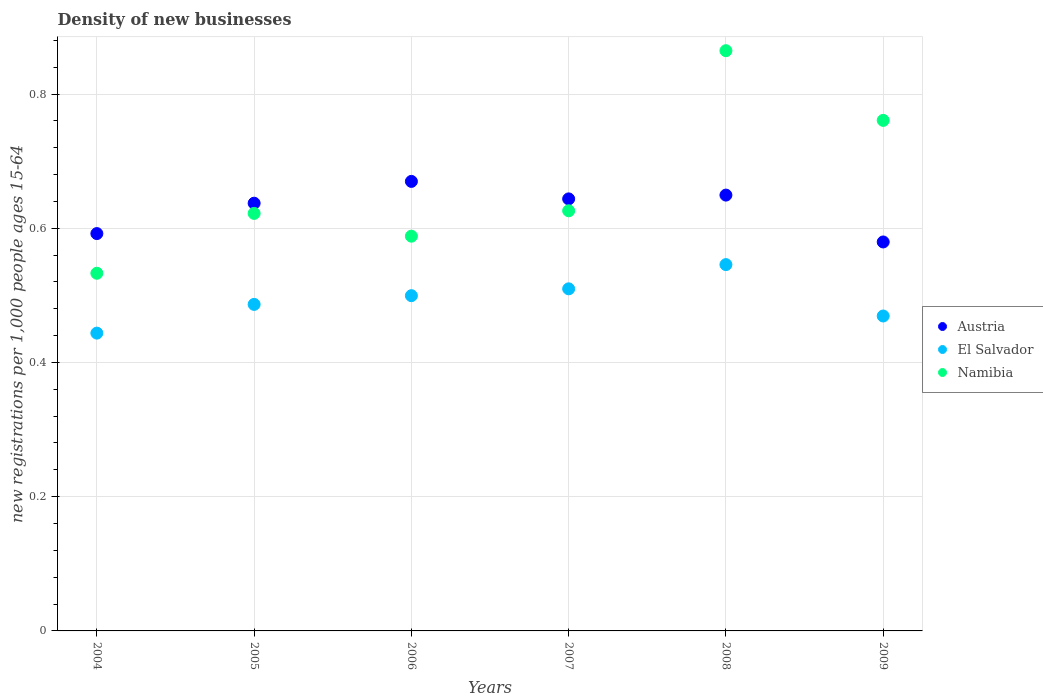Is the number of dotlines equal to the number of legend labels?
Ensure brevity in your answer.  Yes. What is the number of new registrations in Namibia in 2007?
Provide a short and direct response. 0.63. Across all years, what is the maximum number of new registrations in Namibia?
Provide a succinct answer. 0.86. Across all years, what is the minimum number of new registrations in El Salvador?
Offer a very short reply. 0.44. In which year was the number of new registrations in Austria maximum?
Offer a terse response. 2006. In which year was the number of new registrations in Namibia minimum?
Provide a succinct answer. 2004. What is the total number of new registrations in El Salvador in the graph?
Your answer should be compact. 2.95. What is the difference between the number of new registrations in Namibia in 2004 and that in 2006?
Your answer should be very brief. -0.06. What is the difference between the number of new registrations in Austria in 2004 and the number of new registrations in Namibia in 2007?
Your response must be concise. -0.03. What is the average number of new registrations in Austria per year?
Offer a terse response. 0.63. In the year 2005, what is the difference between the number of new registrations in Namibia and number of new registrations in El Salvador?
Make the answer very short. 0.14. In how many years, is the number of new registrations in Austria greater than 0.28?
Provide a short and direct response. 6. What is the ratio of the number of new registrations in El Salvador in 2004 to that in 2009?
Offer a very short reply. 0.95. What is the difference between the highest and the second highest number of new registrations in Namibia?
Your response must be concise. 0.1. What is the difference between the highest and the lowest number of new registrations in Austria?
Ensure brevity in your answer.  0.09. Is the sum of the number of new registrations in Austria in 2004 and 2008 greater than the maximum number of new registrations in Namibia across all years?
Offer a terse response. Yes. Is the number of new registrations in Namibia strictly greater than the number of new registrations in El Salvador over the years?
Your response must be concise. Yes. Is the number of new registrations in Namibia strictly less than the number of new registrations in Austria over the years?
Offer a very short reply. No. What is the difference between two consecutive major ticks on the Y-axis?
Your response must be concise. 0.2. Does the graph contain any zero values?
Offer a very short reply. No. Does the graph contain grids?
Make the answer very short. Yes. Where does the legend appear in the graph?
Provide a short and direct response. Center right. What is the title of the graph?
Make the answer very short. Density of new businesses. Does "Cayman Islands" appear as one of the legend labels in the graph?
Your response must be concise. No. What is the label or title of the X-axis?
Your response must be concise. Years. What is the label or title of the Y-axis?
Provide a succinct answer. New registrations per 1,0 people ages 15-64. What is the new registrations per 1,000 people ages 15-64 in Austria in 2004?
Keep it short and to the point. 0.59. What is the new registrations per 1,000 people ages 15-64 in El Salvador in 2004?
Offer a very short reply. 0.44. What is the new registrations per 1,000 people ages 15-64 in Namibia in 2004?
Give a very brief answer. 0.53. What is the new registrations per 1,000 people ages 15-64 of Austria in 2005?
Provide a short and direct response. 0.64. What is the new registrations per 1,000 people ages 15-64 in El Salvador in 2005?
Offer a terse response. 0.49. What is the new registrations per 1,000 people ages 15-64 of Namibia in 2005?
Your response must be concise. 0.62. What is the new registrations per 1,000 people ages 15-64 in Austria in 2006?
Your answer should be compact. 0.67. What is the new registrations per 1,000 people ages 15-64 of El Salvador in 2006?
Offer a very short reply. 0.5. What is the new registrations per 1,000 people ages 15-64 in Namibia in 2006?
Offer a terse response. 0.59. What is the new registrations per 1,000 people ages 15-64 in Austria in 2007?
Your answer should be compact. 0.64. What is the new registrations per 1,000 people ages 15-64 of El Salvador in 2007?
Your response must be concise. 0.51. What is the new registrations per 1,000 people ages 15-64 in Namibia in 2007?
Ensure brevity in your answer.  0.63. What is the new registrations per 1,000 people ages 15-64 in Austria in 2008?
Keep it short and to the point. 0.65. What is the new registrations per 1,000 people ages 15-64 of El Salvador in 2008?
Give a very brief answer. 0.55. What is the new registrations per 1,000 people ages 15-64 of Namibia in 2008?
Provide a succinct answer. 0.86. What is the new registrations per 1,000 people ages 15-64 in Austria in 2009?
Ensure brevity in your answer.  0.58. What is the new registrations per 1,000 people ages 15-64 of El Salvador in 2009?
Give a very brief answer. 0.47. What is the new registrations per 1,000 people ages 15-64 of Namibia in 2009?
Your answer should be compact. 0.76. Across all years, what is the maximum new registrations per 1,000 people ages 15-64 in Austria?
Offer a terse response. 0.67. Across all years, what is the maximum new registrations per 1,000 people ages 15-64 in El Salvador?
Your answer should be compact. 0.55. Across all years, what is the maximum new registrations per 1,000 people ages 15-64 in Namibia?
Your answer should be very brief. 0.86. Across all years, what is the minimum new registrations per 1,000 people ages 15-64 in Austria?
Offer a terse response. 0.58. Across all years, what is the minimum new registrations per 1,000 people ages 15-64 in El Salvador?
Make the answer very short. 0.44. Across all years, what is the minimum new registrations per 1,000 people ages 15-64 of Namibia?
Offer a terse response. 0.53. What is the total new registrations per 1,000 people ages 15-64 in Austria in the graph?
Your answer should be very brief. 3.77. What is the total new registrations per 1,000 people ages 15-64 in El Salvador in the graph?
Provide a succinct answer. 2.95. What is the total new registrations per 1,000 people ages 15-64 in Namibia in the graph?
Offer a terse response. 3.99. What is the difference between the new registrations per 1,000 people ages 15-64 in Austria in 2004 and that in 2005?
Your answer should be very brief. -0.05. What is the difference between the new registrations per 1,000 people ages 15-64 of El Salvador in 2004 and that in 2005?
Keep it short and to the point. -0.04. What is the difference between the new registrations per 1,000 people ages 15-64 in Namibia in 2004 and that in 2005?
Your answer should be very brief. -0.09. What is the difference between the new registrations per 1,000 people ages 15-64 in Austria in 2004 and that in 2006?
Offer a terse response. -0.08. What is the difference between the new registrations per 1,000 people ages 15-64 in El Salvador in 2004 and that in 2006?
Keep it short and to the point. -0.06. What is the difference between the new registrations per 1,000 people ages 15-64 of Namibia in 2004 and that in 2006?
Ensure brevity in your answer.  -0.06. What is the difference between the new registrations per 1,000 people ages 15-64 in Austria in 2004 and that in 2007?
Make the answer very short. -0.05. What is the difference between the new registrations per 1,000 people ages 15-64 of El Salvador in 2004 and that in 2007?
Offer a terse response. -0.07. What is the difference between the new registrations per 1,000 people ages 15-64 of Namibia in 2004 and that in 2007?
Make the answer very short. -0.09. What is the difference between the new registrations per 1,000 people ages 15-64 of Austria in 2004 and that in 2008?
Make the answer very short. -0.06. What is the difference between the new registrations per 1,000 people ages 15-64 in El Salvador in 2004 and that in 2008?
Provide a succinct answer. -0.1. What is the difference between the new registrations per 1,000 people ages 15-64 in Namibia in 2004 and that in 2008?
Make the answer very short. -0.33. What is the difference between the new registrations per 1,000 people ages 15-64 in Austria in 2004 and that in 2009?
Provide a short and direct response. 0.01. What is the difference between the new registrations per 1,000 people ages 15-64 in El Salvador in 2004 and that in 2009?
Keep it short and to the point. -0.03. What is the difference between the new registrations per 1,000 people ages 15-64 in Namibia in 2004 and that in 2009?
Offer a terse response. -0.23. What is the difference between the new registrations per 1,000 people ages 15-64 of Austria in 2005 and that in 2006?
Keep it short and to the point. -0.03. What is the difference between the new registrations per 1,000 people ages 15-64 in El Salvador in 2005 and that in 2006?
Make the answer very short. -0.01. What is the difference between the new registrations per 1,000 people ages 15-64 in Namibia in 2005 and that in 2006?
Make the answer very short. 0.03. What is the difference between the new registrations per 1,000 people ages 15-64 in Austria in 2005 and that in 2007?
Your answer should be very brief. -0.01. What is the difference between the new registrations per 1,000 people ages 15-64 in El Salvador in 2005 and that in 2007?
Keep it short and to the point. -0.02. What is the difference between the new registrations per 1,000 people ages 15-64 in Namibia in 2005 and that in 2007?
Keep it short and to the point. -0. What is the difference between the new registrations per 1,000 people ages 15-64 of Austria in 2005 and that in 2008?
Offer a terse response. -0.01. What is the difference between the new registrations per 1,000 people ages 15-64 of El Salvador in 2005 and that in 2008?
Offer a terse response. -0.06. What is the difference between the new registrations per 1,000 people ages 15-64 of Namibia in 2005 and that in 2008?
Provide a short and direct response. -0.24. What is the difference between the new registrations per 1,000 people ages 15-64 of Austria in 2005 and that in 2009?
Ensure brevity in your answer.  0.06. What is the difference between the new registrations per 1,000 people ages 15-64 of El Salvador in 2005 and that in 2009?
Your answer should be very brief. 0.02. What is the difference between the new registrations per 1,000 people ages 15-64 in Namibia in 2005 and that in 2009?
Offer a terse response. -0.14. What is the difference between the new registrations per 1,000 people ages 15-64 of Austria in 2006 and that in 2007?
Ensure brevity in your answer.  0.03. What is the difference between the new registrations per 1,000 people ages 15-64 in El Salvador in 2006 and that in 2007?
Offer a very short reply. -0.01. What is the difference between the new registrations per 1,000 people ages 15-64 in Namibia in 2006 and that in 2007?
Give a very brief answer. -0.04. What is the difference between the new registrations per 1,000 people ages 15-64 in Austria in 2006 and that in 2008?
Your response must be concise. 0.02. What is the difference between the new registrations per 1,000 people ages 15-64 of El Salvador in 2006 and that in 2008?
Give a very brief answer. -0.05. What is the difference between the new registrations per 1,000 people ages 15-64 in Namibia in 2006 and that in 2008?
Make the answer very short. -0.28. What is the difference between the new registrations per 1,000 people ages 15-64 of Austria in 2006 and that in 2009?
Offer a very short reply. 0.09. What is the difference between the new registrations per 1,000 people ages 15-64 in El Salvador in 2006 and that in 2009?
Give a very brief answer. 0.03. What is the difference between the new registrations per 1,000 people ages 15-64 of Namibia in 2006 and that in 2009?
Offer a terse response. -0.17. What is the difference between the new registrations per 1,000 people ages 15-64 of Austria in 2007 and that in 2008?
Keep it short and to the point. -0.01. What is the difference between the new registrations per 1,000 people ages 15-64 of El Salvador in 2007 and that in 2008?
Provide a succinct answer. -0.04. What is the difference between the new registrations per 1,000 people ages 15-64 of Namibia in 2007 and that in 2008?
Give a very brief answer. -0.24. What is the difference between the new registrations per 1,000 people ages 15-64 in Austria in 2007 and that in 2009?
Make the answer very short. 0.06. What is the difference between the new registrations per 1,000 people ages 15-64 in El Salvador in 2007 and that in 2009?
Your answer should be very brief. 0.04. What is the difference between the new registrations per 1,000 people ages 15-64 of Namibia in 2007 and that in 2009?
Your answer should be very brief. -0.13. What is the difference between the new registrations per 1,000 people ages 15-64 of Austria in 2008 and that in 2009?
Make the answer very short. 0.07. What is the difference between the new registrations per 1,000 people ages 15-64 of El Salvador in 2008 and that in 2009?
Give a very brief answer. 0.08. What is the difference between the new registrations per 1,000 people ages 15-64 in Namibia in 2008 and that in 2009?
Offer a very short reply. 0.1. What is the difference between the new registrations per 1,000 people ages 15-64 of Austria in 2004 and the new registrations per 1,000 people ages 15-64 of El Salvador in 2005?
Offer a very short reply. 0.11. What is the difference between the new registrations per 1,000 people ages 15-64 in Austria in 2004 and the new registrations per 1,000 people ages 15-64 in Namibia in 2005?
Your answer should be compact. -0.03. What is the difference between the new registrations per 1,000 people ages 15-64 in El Salvador in 2004 and the new registrations per 1,000 people ages 15-64 in Namibia in 2005?
Ensure brevity in your answer.  -0.18. What is the difference between the new registrations per 1,000 people ages 15-64 in Austria in 2004 and the new registrations per 1,000 people ages 15-64 in El Salvador in 2006?
Your answer should be very brief. 0.09. What is the difference between the new registrations per 1,000 people ages 15-64 in Austria in 2004 and the new registrations per 1,000 people ages 15-64 in Namibia in 2006?
Your answer should be very brief. 0. What is the difference between the new registrations per 1,000 people ages 15-64 in El Salvador in 2004 and the new registrations per 1,000 people ages 15-64 in Namibia in 2006?
Provide a succinct answer. -0.14. What is the difference between the new registrations per 1,000 people ages 15-64 in Austria in 2004 and the new registrations per 1,000 people ages 15-64 in El Salvador in 2007?
Your response must be concise. 0.08. What is the difference between the new registrations per 1,000 people ages 15-64 of Austria in 2004 and the new registrations per 1,000 people ages 15-64 of Namibia in 2007?
Give a very brief answer. -0.03. What is the difference between the new registrations per 1,000 people ages 15-64 of El Salvador in 2004 and the new registrations per 1,000 people ages 15-64 of Namibia in 2007?
Provide a succinct answer. -0.18. What is the difference between the new registrations per 1,000 people ages 15-64 of Austria in 2004 and the new registrations per 1,000 people ages 15-64 of El Salvador in 2008?
Give a very brief answer. 0.05. What is the difference between the new registrations per 1,000 people ages 15-64 in Austria in 2004 and the new registrations per 1,000 people ages 15-64 in Namibia in 2008?
Your answer should be compact. -0.27. What is the difference between the new registrations per 1,000 people ages 15-64 of El Salvador in 2004 and the new registrations per 1,000 people ages 15-64 of Namibia in 2008?
Your response must be concise. -0.42. What is the difference between the new registrations per 1,000 people ages 15-64 of Austria in 2004 and the new registrations per 1,000 people ages 15-64 of El Salvador in 2009?
Your answer should be compact. 0.12. What is the difference between the new registrations per 1,000 people ages 15-64 of Austria in 2004 and the new registrations per 1,000 people ages 15-64 of Namibia in 2009?
Make the answer very short. -0.17. What is the difference between the new registrations per 1,000 people ages 15-64 in El Salvador in 2004 and the new registrations per 1,000 people ages 15-64 in Namibia in 2009?
Offer a very short reply. -0.32. What is the difference between the new registrations per 1,000 people ages 15-64 in Austria in 2005 and the new registrations per 1,000 people ages 15-64 in El Salvador in 2006?
Make the answer very short. 0.14. What is the difference between the new registrations per 1,000 people ages 15-64 in Austria in 2005 and the new registrations per 1,000 people ages 15-64 in Namibia in 2006?
Your answer should be compact. 0.05. What is the difference between the new registrations per 1,000 people ages 15-64 of El Salvador in 2005 and the new registrations per 1,000 people ages 15-64 of Namibia in 2006?
Your answer should be compact. -0.1. What is the difference between the new registrations per 1,000 people ages 15-64 in Austria in 2005 and the new registrations per 1,000 people ages 15-64 in El Salvador in 2007?
Your response must be concise. 0.13. What is the difference between the new registrations per 1,000 people ages 15-64 of Austria in 2005 and the new registrations per 1,000 people ages 15-64 of Namibia in 2007?
Make the answer very short. 0.01. What is the difference between the new registrations per 1,000 people ages 15-64 in El Salvador in 2005 and the new registrations per 1,000 people ages 15-64 in Namibia in 2007?
Your answer should be very brief. -0.14. What is the difference between the new registrations per 1,000 people ages 15-64 of Austria in 2005 and the new registrations per 1,000 people ages 15-64 of El Salvador in 2008?
Provide a short and direct response. 0.09. What is the difference between the new registrations per 1,000 people ages 15-64 of Austria in 2005 and the new registrations per 1,000 people ages 15-64 of Namibia in 2008?
Offer a very short reply. -0.23. What is the difference between the new registrations per 1,000 people ages 15-64 in El Salvador in 2005 and the new registrations per 1,000 people ages 15-64 in Namibia in 2008?
Give a very brief answer. -0.38. What is the difference between the new registrations per 1,000 people ages 15-64 of Austria in 2005 and the new registrations per 1,000 people ages 15-64 of El Salvador in 2009?
Your response must be concise. 0.17. What is the difference between the new registrations per 1,000 people ages 15-64 of Austria in 2005 and the new registrations per 1,000 people ages 15-64 of Namibia in 2009?
Your answer should be very brief. -0.12. What is the difference between the new registrations per 1,000 people ages 15-64 in El Salvador in 2005 and the new registrations per 1,000 people ages 15-64 in Namibia in 2009?
Offer a terse response. -0.27. What is the difference between the new registrations per 1,000 people ages 15-64 of Austria in 2006 and the new registrations per 1,000 people ages 15-64 of El Salvador in 2007?
Give a very brief answer. 0.16. What is the difference between the new registrations per 1,000 people ages 15-64 of Austria in 2006 and the new registrations per 1,000 people ages 15-64 of Namibia in 2007?
Offer a very short reply. 0.04. What is the difference between the new registrations per 1,000 people ages 15-64 of El Salvador in 2006 and the new registrations per 1,000 people ages 15-64 of Namibia in 2007?
Offer a terse response. -0.13. What is the difference between the new registrations per 1,000 people ages 15-64 in Austria in 2006 and the new registrations per 1,000 people ages 15-64 in El Salvador in 2008?
Provide a succinct answer. 0.12. What is the difference between the new registrations per 1,000 people ages 15-64 of Austria in 2006 and the new registrations per 1,000 people ages 15-64 of Namibia in 2008?
Give a very brief answer. -0.19. What is the difference between the new registrations per 1,000 people ages 15-64 in El Salvador in 2006 and the new registrations per 1,000 people ages 15-64 in Namibia in 2008?
Offer a very short reply. -0.36. What is the difference between the new registrations per 1,000 people ages 15-64 in Austria in 2006 and the new registrations per 1,000 people ages 15-64 in El Salvador in 2009?
Your answer should be very brief. 0.2. What is the difference between the new registrations per 1,000 people ages 15-64 of Austria in 2006 and the new registrations per 1,000 people ages 15-64 of Namibia in 2009?
Offer a terse response. -0.09. What is the difference between the new registrations per 1,000 people ages 15-64 in El Salvador in 2006 and the new registrations per 1,000 people ages 15-64 in Namibia in 2009?
Ensure brevity in your answer.  -0.26. What is the difference between the new registrations per 1,000 people ages 15-64 of Austria in 2007 and the new registrations per 1,000 people ages 15-64 of El Salvador in 2008?
Provide a short and direct response. 0.1. What is the difference between the new registrations per 1,000 people ages 15-64 in Austria in 2007 and the new registrations per 1,000 people ages 15-64 in Namibia in 2008?
Your response must be concise. -0.22. What is the difference between the new registrations per 1,000 people ages 15-64 of El Salvador in 2007 and the new registrations per 1,000 people ages 15-64 of Namibia in 2008?
Your answer should be very brief. -0.35. What is the difference between the new registrations per 1,000 people ages 15-64 in Austria in 2007 and the new registrations per 1,000 people ages 15-64 in El Salvador in 2009?
Your response must be concise. 0.17. What is the difference between the new registrations per 1,000 people ages 15-64 of Austria in 2007 and the new registrations per 1,000 people ages 15-64 of Namibia in 2009?
Provide a short and direct response. -0.12. What is the difference between the new registrations per 1,000 people ages 15-64 of El Salvador in 2007 and the new registrations per 1,000 people ages 15-64 of Namibia in 2009?
Provide a short and direct response. -0.25. What is the difference between the new registrations per 1,000 people ages 15-64 of Austria in 2008 and the new registrations per 1,000 people ages 15-64 of El Salvador in 2009?
Your response must be concise. 0.18. What is the difference between the new registrations per 1,000 people ages 15-64 in Austria in 2008 and the new registrations per 1,000 people ages 15-64 in Namibia in 2009?
Provide a succinct answer. -0.11. What is the difference between the new registrations per 1,000 people ages 15-64 in El Salvador in 2008 and the new registrations per 1,000 people ages 15-64 in Namibia in 2009?
Your answer should be very brief. -0.21. What is the average new registrations per 1,000 people ages 15-64 in Austria per year?
Your response must be concise. 0.63. What is the average new registrations per 1,000 people ages 15-64 of El Salvador per year?
Give a very brief answer. 0.49. What is the average new registrations per 1,000 people ages 15-64 in Namibia per year?
Ensure brevity in your answer.  0.67. In the year 2004, what is the difference between the new registrations per 1,000 people ages 15-64 of Austria and new registrations per 1,000 people ages 15-64 of El Salvador?
Make the answer very short. 0.15. In the year 2004, what is the difference between the new registrations per 1,000 people ages 15-64 of Austria and new registrations per 1,000 people ages 15-64 of Namibia?
Provide a short and direct response. 0.06. In the year 2004, what is the difference between the new registrations per 1,000 people ages 15-64 in El Salvador and new registrations per 1,000 people ages 15-64 in Namibia?
Make the answer very short. -0.09. In the year 2005, what is the difference between the new registrations per 1,000 people ages 15-64 in Austria and new registrations per 1,000 people ages 15-64 in El Salvador?
Your response must be concise. 0.15. In the year 2005, what is the difference between the new registrations per 1,000 people ages 15-64 of Austria and new registrations per 1,000 people ages 15-64 of Namibia?
Provide a succinct answer. 0.02. In the year 2005, what is the difference between the new registrations per 1,000 people ages 15-64 in El Salvador and new registrations per 1,000 people ages 15-64 in Namibia?
Offer a very short reply. -0.14. In the year 2006, what is the difference between the new registrations per 1,000 people ages 15-64 of Austria and new registrations per 1,000 people ages 15-64 of El Salvador?
Provide a succinct answer. 0.17. In the year 2006, what is the difference between the new registrations per 1,000 people ages 15-64 in Austria and new registrations per 1,000 people ages 15-64 in Namibia?
Offer a terse response. 0.08. In the year 2006, what is the difference between the new registrations per 1,000 people ages 15-64 of El Salvador and new registrations per 1,000 people ages 15-64 of Namibia?
Make the answer very short. -0.09. In the year 2007, what is the difference between the new registrations per 1,000 people ages 15-64 in Austria and new registrations per 1,000 people ages 15-64 in El Salvador?
Provide a short and direct response. 0.13. In the year 2007, what is the difference between the new registrations per 1,000 people ages 15-64 in Austria and new registrations per 1,000 people ages 15-64 in Namibia?
Give a very brief answer. 0.02. In the year 2007, what is the difference between the new registrations per 1,000 people ages 15-64 of El Salvador and new registrations per 1,000 people ages 15-64 of Namibia?
Give a very brief answer. -0.12. In the year 2008, what is the difference between the new registrations per 1,000 people ages 15-64 in Austria and new registrations per 1,000 people ages 15-64 in El Salvador?
Offer a very short reply. 0.1. In the year 2008, what is the difference between the new registrations per 1,000 people ages 15-64 of Austria and new registrations per 1,000 people ages 15-64 of Namibia?
Your response must be concise. -0.22. In the year 2008, what is the difference between the new registrations per 1,000 people ages 15-64 in El Salvador and new registrations per 1,000 people ages 15-64 in Namibia?
Make the answer very short. -0.32. In the year 2009, what is the difference between the new registrations per 1,000 people ages 15-64 of Austria and new registrations per 1,000 people ages 15-64 of El Salvador?
Provide a short and direct response. 0.11. In the year 2009, what is the difference between the new registrations per 1,000 people ages 15-64 in Austria and new registrations per 1,000 people ages 15-64 in Namibia?
Give a very brief answer. -0.18. In the year 2009, what is the difference between the new registrations per 1,000 people ages 15-64 of El Salvador and new registrations per 1,000 people ages 15-64 of Namibia?
Keep it short and to the point. -0.29. What is the ratio of the new registrations per 1,000 people ages 15-64 in Austria in 2004 to that in 2005?
Your response must be concise. 0.93. What is the ratio of the new registrations per 1,000 people ages 15-64 in El Salvador in 2004 to that in 2005?
Provide a short and direct response. 0.91. What is the ratio of the new registrations per 1,000 people ages 15-64 of Namibia in 2004 to that in 2005?
Offer a terse response. 0.86. What is the ratio of the new registrations per 1,000 people ages 15-64 in Austria in 2004 to that in 2006?
Ensure brevity in your answer.  0.88. What is the ratio of the new registrations per 1,000 people ages 15-64 in El Salvador in 2004 to that in 2006?
Give a very brief answer. 0.89. What is the ratio of the new registrations per 1,000 people ages 15-64 of Namibia in 2004 to that in 2006?
Make the answer very short. 0.91. What is the ratio of the new registrations per 1,000 people ages 15-64 in Austria in 2004 to that in 2007?
Offer a terse response. 0.92. What is the ratio of the new registrations per 1,000 people ages 15-64 of El Salvador in 2004 to that in 2007?
Make the answer very short. 0.87. What is the ratio of the new registrations per 1,000 people ages 15-64 of Namibia in 2004 to that in 2007?
Your answer should be compact. 0.85. What is the ratio of the new registrations per 1,000 people ages 15-64 of Austria in 2004 to that in 2008?
Offer a very short reply. 0.91. What is the ratio of the new registrations per 1,000 people ages 15-64 of El Salvador in 2004 to that in 2008?
Your answer should be very brief. 0.81. What is the ratio of the new registrations per 1,000 people ages 15-64 in Namibia in 2004 to that in 2008?
Give a very brief answer. 0.62. What is the ratio of the new registrations per 1,000 people ages 15-64 in Austria in 2004 to that in 2009?
Make the answer very short. 1.02. What is the ratio of the new registrations per 1,000 people ages 15-64 of El Salvador in 2004 to that in 2009?
Provide a short and direct response. 0.95. What is the ratio of the new registrations per 1,000 people ages 15-64 of Namibia in 2004 to that in 2009?
Make the answer very short. 0.7. What is the ratio of the new registrations per 1,000 people ages 15-64 of Austria in 2005 to that in 2006?
Your answer should be very brief. 0.95. What is the ratio of the new registrations per 1,000 people ages 15-64 of El Salvador in 2005 to that in 2006?
Make the answer very short. 0.97. What is the ratio of the new registrations per 1,000 people ages 15-64 of Namibia in 2005 to that in 2006?
Your answer should be compact. 1.06. What is the ratio of the new registrations per 1,000 people ages 15-64 in El Salvador in 2005 to that in 2007?
Keep it short and to the point. 0.95. What is the ratio of the new registrations per 1,000 people ages 15-64 of Austria in 2005 to that in 2008?
Provide a succinct answer. 0.98. What is the ratio of the new registrations per 1,000 people ages 15-64 in El Salvador in 2005 to that in 2008?
Ensure brevity in your answer.  0.89. What is the ratio of the new registrations per 1,000 people ages 15-64 in Namibia in 2005 to that in 2008?
Provide a short and direct response. 0.72. What is the ratio of the new registrations per 1,000 people ages 15-64 in Austria in 2005 to that in 2009?
Make the answer very short. 1.1. What is the ratio of the new registrations per 1,000 people ages 15-64 of El Salvador in 2005 to that in 2009?
Give a very brief answer. 1.04. What is the ratio of the new registrations per 1,000 people ages 15-64 in Namibia in 2005 to that in 2009?
Make the answer very short. 0.82. What is the ratio of the new registrations per 1,000 people ages 15-64 in Austria in 2006 to that in 2007?
Give a very brief answer. 1.04. What is the ratio of the new registrations per 1,000 people ages 15-64 in Namibia in 2006 to that in 2007?
Provide a short and direct response. 0.94. What is the ratio of the new registrations per 1,000 people ages 15-64 in Austria in 2006 to that in 2008?
Make the answer very short. 1.03. What is the ratio of the new registrations per 1,000 people ages 15-64 in El Salvador in 2006 to that in 2008?
Provide a short and direct response. 0.92. What is the ratio of the new registrations per 1,000 people ages 15-64 of Namibia in 2006 to that in 2008?
Offer a very short reply. 0.68. What is the ratio of the new registrations per 1,000 people ages 15-64 of Austria in 2006 to that in 2009?
Provide a short and direct response. 1.16. What is the ratio of the new registrations per 1,000 people ages 15-64 of El Salvador in 2006 to that in 2009?
Your answer should be compact. 1.06. What is the ratio of the new registrations per 1,000 people ages 15-64 in Namibia in 2006 to that in 2009?
Offer a very short reply. 0.77. What is the ratio of the new registrations per 1,000 people ages 15-64 of El Salvador in 2007 to that in 2008?
Your response must be concise. 0.93. What is the ratio of the new registrations per 1,000 people ages 15-64 of Namibia in 2007 to that in 2008?
Ensure brevity in your answer.  0.72. What is the ratio of the new registrations per 1,000 people ages 15-64 in Austria in 2007 to that in 2009?
Your response must be concise. 1.11. What is the ratio of the new registrations per 1,000 people ages 15-64 in El Salvador in 2007 to that in 2009?
Offer a terse response. 1.09. What is the ratio of the new registrations per 1,000 people ages 15-64 in Namibia in 2007 to that in 2009?
Offer a terse response. 0.82. What is the ratio of the new registrations per 1,000 people ages 15-64 of Austria in 2008 to that in 2009?
Provide a short and direct response. 1.12. What is the ratio of the new registrations per 1,000 people ages 15-64 of El Salvador in 2008 to that in 2009?
Provide a succinct answer. 1.16. What is the ratio of the new registrations per 1,000 people ages 15-64 of Namibia in 2008 to that in 2009?
Offer a terse response. 1.14. What is the difference between the highest and the second highest new registrations per 1,000 people ages 15-64 in Austria?
Your response must be concise. 0.02. What is the difference between the highest and the second highest new registrations per 1,000 people ages 15-64 of El Salvador?
Your response must be concise. 0.04. What is the difference between the highest and the second highest new registrations per 1,000 people ages 15-64 of Namibia?
Offer a very short reply. 0.1. What is the difference between the highest and the lowest new registrations per 1,000 people ages 15-64 of Austria?
Your answer should be compact. 0.09. What is the difference between the highest and the lowest new registrations per 1,000 people ages 15-64 of El Salvador?
Give a very brief answer. 0.1. What is the difference between the highest and the lowest new registrations per 1,000 people ages 15-64 of Namibia?
Offer a very short reply. 0.33. 